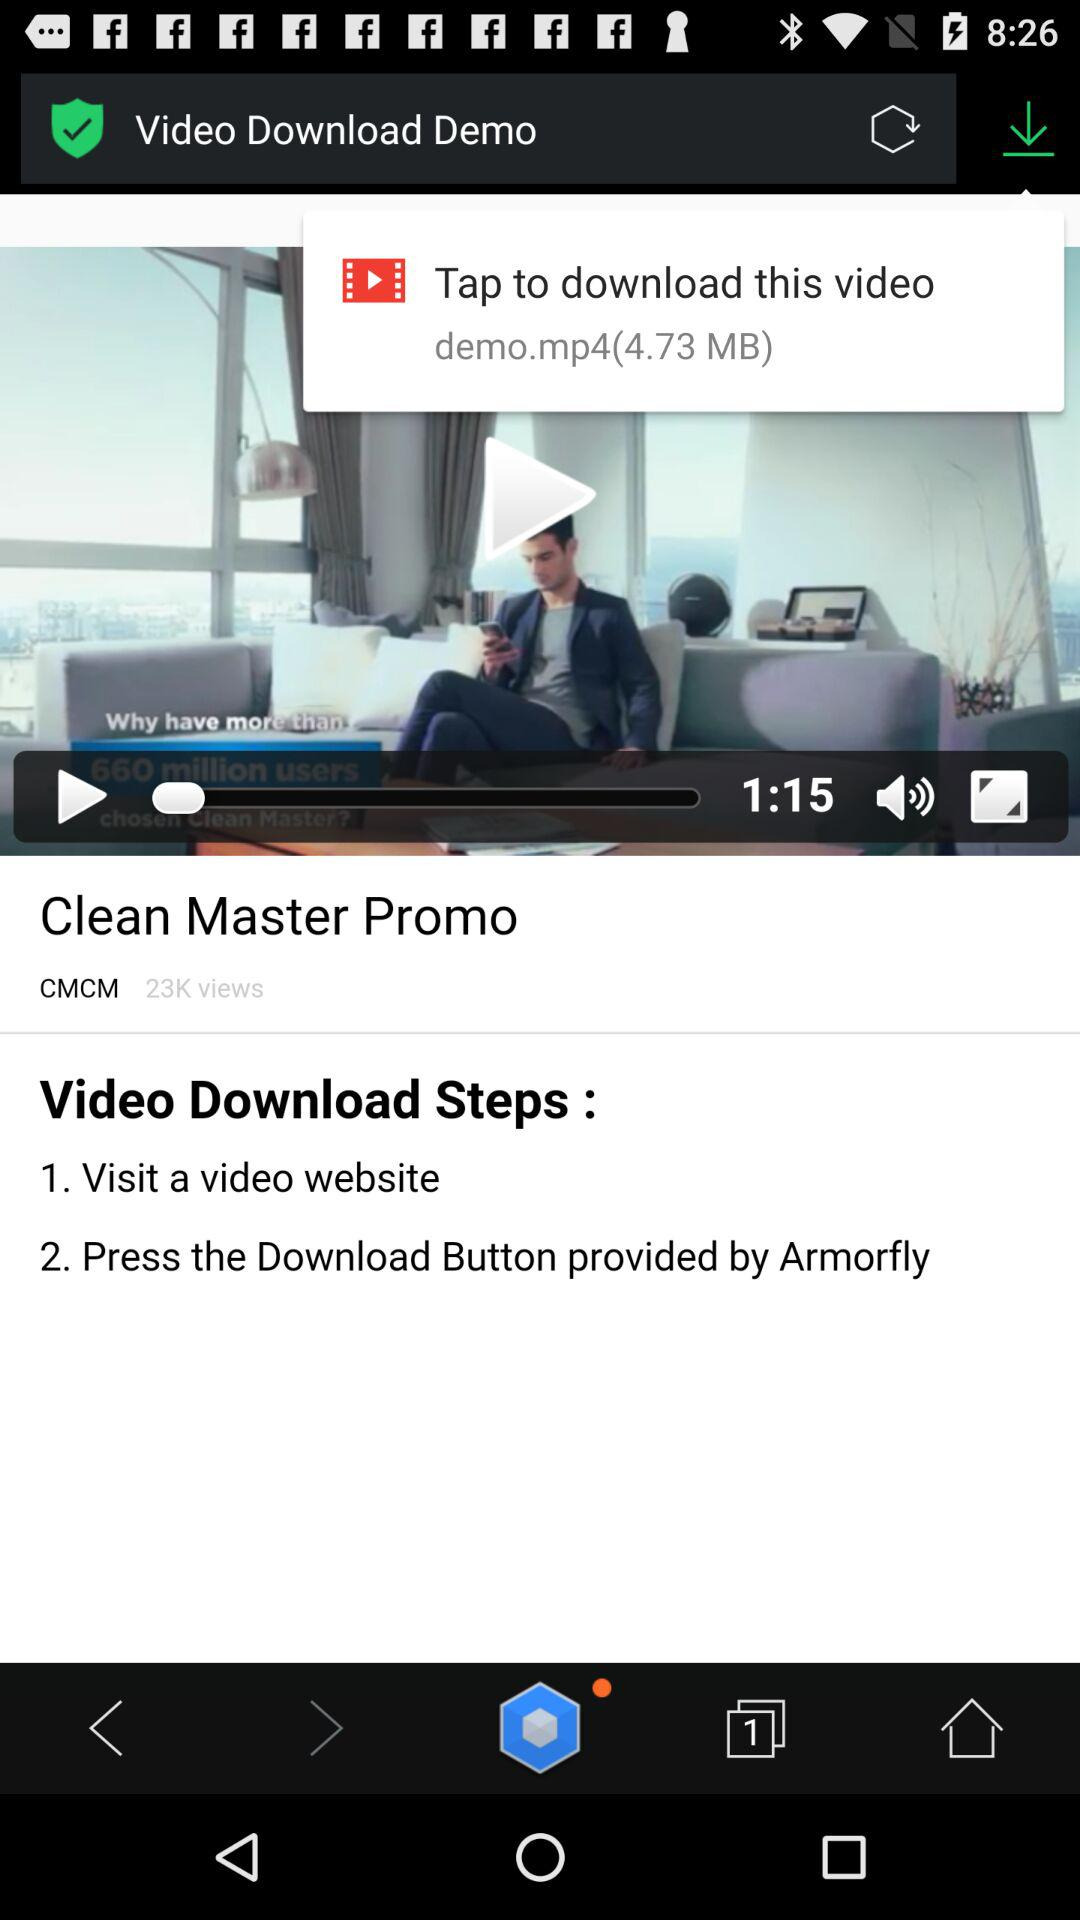How much does the video file weigh?
Answer the question using a single word or phrase. 4.73 MB 